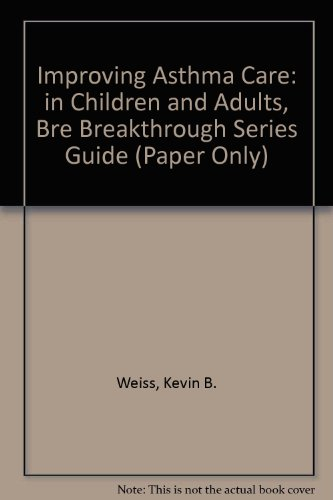What specific topics does this book cover regarding asthma? This book offers insights into effective strategies for asthma management, including clinical practices for better patient care and system improvements in both pediatric and adult settings. 